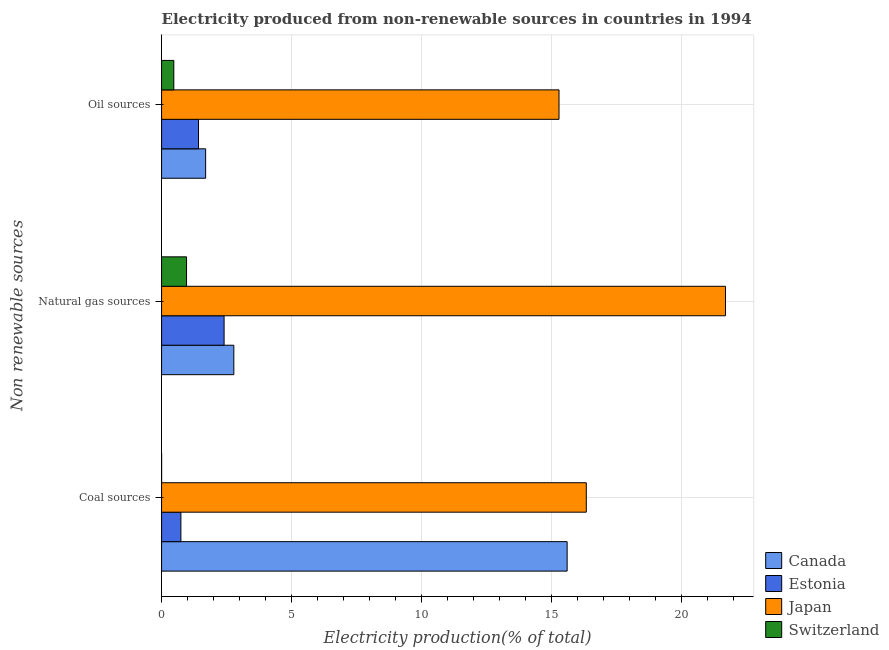How many groups of bars are there?
Keep it short and to the point. 3. Are the number of bars per tick equal to the number of legend labels?
Your answer should be compact. Yes. Are the number of bars on each tick of the Y-axis equal?
Provide a succinct answer. Yes. How many bars are there on the 2nd tick from the top?
Give a very brief answer. 4. What is the label of the 3rd group of bars from the top?
Keep it short and to the point. Coal sources. What is the percentage of electricity produced by oil sources in Estonia?
Ensure brevity in your answer.  1.42. Across all countries, what is the maximum percentage of electricity produced by natural gas?
Provide a succinct answer. 21.68. Across all countries, what is the minimum percentage of electricity produced by oil sources?
Your answer should be compact. 0.47. In which country was the percentage of electricity produced by natural gas minimum?
Provide a succinct answer. Switzerland. What is the total percentage of electricity produced by coal in the graph?
Offer a terse response. 32.67. What is the difference between the percentage of electricity produced by coal in Estonia and that in Switzerland?
Provide a succinct answer. 0.74. What is the difference between the percentage of electricity produced by natural gas in Japan and the percentage of electricity produced by oil sources in Estonia?
Make the answer very short. 20.26. What is the average percentage of electricity produced by oil sources per country?
Your answer should be very brief. 4.72. What is the difference between the percentage of electricity produced by natural gas and percentage of electricity produced by oil sources in Japan?
Offer a very short reply. 6.4. In how many countries, is the percentage of electricity produced by oil sources greater than 5 %?
Your response must be concise. 1. What is the ratio of the percentage of electricity produced by coal in Switzerland to that in Japan?
Keep it short and to the point. 9.359942458074121e-5. Is the difference between the percentage of electricity produced by natural gas in Canada and Switzerland greater than the difference between the percentage of electricity produced by oil sources in Canada and Switzerland?
Ensure brevity in your answer.  Yes. What is the difference between the highest and the second highest percentage of electricity produced by oil sources?
Offer a terse response. 13.59. What is the difference between the highest and the lowest percentage of electricity produced by oil sources?
Offer a terse response. 14.81. What does the 1st bar from the top in Oil sources represents?
Offer a very short reply. Switzerland. What does the 1st bar from the bottom in Oil sources represents?
Give a very brief answer. Canada. Is it the case that in every country, the sum of the percentage of electricity produced by coal and percentage of electricity produced by natural gas is greater than the percentage of electricity produced by oil sources?
Your answer should be compact. Yes. How many countries are there in the graph?
Your answer should be compact. 4. What is the difference between two consecutive major ticks on the X-axis?
Your answer should be very brief. 5. Are the values on the major ticks of X-axis written in scientific E-notation?
Provide a short and direct response. No. Does the graph contain any zero values?
Keep it short and to the point. No. Where does the legend appear in the graph?
Your response must be concise. Bottom right. How are the legend labels stacked?
Your response must be concise. Vertical. What is the title of the graph?
Offer a very short reply. Electricity produced from non-renewable sources in countries in 1994. What is the label or title of the X-axis?
Your answer should be very brief. Electricity production(% of total). What is the label or title of the Y-axis?
Your answer should be compact. Non renewable sources. What is the Electricity production(% of total) of Canada in Coal sources?
Offer a terse response. 15.59. What is the Electricity production(% of total) in Estonia in Coal sources?
Make the answer very short. 0.74. What is the Electricity production(% of total) in Japan in Coal sources?
Provide a succinct answer. 16.33. What is the Electricity production(% of total) in Switzerland in Coal sources?
Your answer should be very brief. 0. What is the Electricity production(% of total) in Canada in Natural gas sources?
Give a very brief answer. 2.78. What is the Electricity production(% of total) of Estonia in Natural gas sources?
Make the answer very short. 2.4. What is the Electricity production(% of total) of Japan in Natural gas sources?
Provide a succinct answer. 21.68. What is the Electricity production(% of total) in Switzerland in Natural gas sources?
Offer a very short reply. 0.96. What is the Electricity production(% of total) of Canada in Oil sources?
Provide a succinct answer. 1.69. What is the Electricity production(% of total) in Estonia in Oil sources?
Offer a terse response. 1.42. What is the Electricity production(% of total) in Japan in Oil sources?
Keep it short and to the point. 15.28. What is the Electricity production(% of total) in Switzerland in Oil sources?
Keep it short and to the point. 0.47. Across all Non renewable sources, what is the maximum Electricity production(% of total) in Canada?
Your answer should be very brief. 15.59. Across all Non renewable sources, what is the maximum Electricity production(% of total) of Estonia?
Your response must be concise. 2.4. Across all Non renewable sources, what is the maximum Electricity production(% of total) of Japan?
Offer a very short reply. 21.68. Across all Non renewable sources, what is the maximum Electricity production(% of total) of Switzerland?
Offer a very short reply. 0.96. Across all Non renewable sources, what is the minimum Electricity production(% of total) of Canada?
Your answer should be compact. 1.69. Across all Non renewable sources, what is the minimum Electricity production(% of total) of Estonia?
Provide a succinct answer. 0.74. Across all Non renewable sources, what is the minimum Electricity production(% of total) in Japan?
Your response must be concise. 15.28. Across all Non renewable sources, what is the minimum Electricity production(% of total) of Switzerland?
Provide a short and direct response. 0. What is the total Electricity production(% of total) in Canada in the graph?
Provide a short and direct response. 20.07. What is the total Electricity production(% of total) of Estonia in the graph?
Offer a very short reply. 4.57. What is the total Electricity production(% of total) of Japan in the graph?
Make the answer very short. 53.29. What is the total Electricity production(% of total) in Switzerland in the graph?
Your response must be concise. 1.43. What is the difference between the Electricity production(% of total) of Canada in Coal sources and that in Natural gas sources?
Provide a short and direct response. 12.82. What is the difference between the Electricity production(% of total) of Estonia in Coal sources and that in Natural gas sources?
Provide a succinct answer. -1.66. What is the difference between the Electricity production(% of total) in Japan in Coal sources and that in Natural gas sources?
Offer a terse response. -5.35. What is the difference between the Electricity production(% of total) of Switzerland in Coal sources and that in Natural gas sources?
Provide a succinct answer. -0.96. What is the difference between the Electricity production(% of total) in Canada in Coal sources and that in Oil sources?
Give a very brief answer. 13.9. What is the difference between the Electricity production(% of total) of Estonia in Coal sources and that in Oil sources?
Offer a very short reply. -0.68. What is the difference between the Electricity production(% of total) in Japan in Coal sources and that in Oil sources?
Offer a very short reply. 1.05. What is the difference between the Electricity production(% of total) of Switzerland in Coal sources and that in Oil sources?
Your answer should be very brief. -0.47. What is the difference between the Electricity production(% of total) of Canada in Natural gas sources and that in Oil sources?
Offer a very short reply. 1.08. What is the difference between the Electricity production(% of total) in Estonia in Natural gas sources and that in Oil sources?
Make the answer very short. 0.98. What is the difference between the Electricity production(% of total) in Japan in Natural gas sources and that in Oil sources?
Your response must be concise. 6.4. What is the difference between the Electricity production(% of total) of Switzerland in Natural gas sources and that in Oil sources?
Your answer should be compact. 0.49. What is the difference between the Electricity production(% of total) of Canada in Coal sources and the Electricity production(% of total) of Estonia in Natural gas sources?
Keep it short and to the point. 13.19. What is the difference between the Electricity production(% of total) of Canada in Coal sources and the Electricity production(% of total) of Japan in Natural gas sources?
Your response must be concise. -6.09. What is the difference between the Electricity production(% of total) in Canada in Coal sources and the Electricity production(% of total) in Switzerland in Natural gas sources?
Give a very brief answer. 14.63. What is the difference between the Electricity production(% of total) of Estonia in Coal sources and the Electricity production(% of total) of Japan in Natural gas sources?
Your answer should be compact. -20.94. What is the difference between the Electricity production(% of total) in Estonia in Coal sources and the Electricity production(% of total) in Switzerland in Natural gas sources?
Ensure brevity in your answer.  -0.22. What is the difference between the Electricity production(% of total) in Japan in Coal sources and the Electricity production(% of total) in Switzerland in Natural gas sources?
Your answer should be very brief. 15.37. What is the difference between the Electricity production(% of total) of Canada in Coal sources and the Electricity production(% of total) of Estonia in Oil sources?
Ensure brevity in your answer.  14.17. What is the difference between the Electricity production(% of total) in Canada in Coal sources and the Electricity production(% of total) in Japan in Oil sources?
Keep it short and to the point. 0.31. What is the difference between the Electricity production(% of total) in Canada in Coal sources and the Electricity production(% of total) in Switzerland in Oil sources?
Provide a succinct answer. 15.12. What is the difference between the Electricity production(% of total) of Estonia in Coal sources and the Electricity production(% of total) of Japan in Oil sources?
Provide a succinct answer. -14.54. What is the difference between the Electricity production(% of total) of Estonia in Coal sources and the Electricity production(% of total) of Switzerland in Oil sources?
Your answer should be compact. 0.27. What is the difference between the Electricity production(% of total) of Japan in Coal sources and the Electricity production(% of total) of Switzerland in Oil sources?
Make the answer very short. 15.86. What is the difference between the Electricity production(% of total) in Canada in Natural gas sources and the Electricity production(% of total) in Estonia in Oil sources?
Offer a very short reply. 1.36. What is the difference between the Electricity production(% of total) of Canada in Natural gas sources and the Electricity production(% of total) of Japan in Oil sources?
Keep it short and to the point. -12.5. What is the difference between the Electricity production(% of total) in Canada in Natural gas sources and the Electricity production(% of total) in Switzerland in Oil sources?
Make the answer very short. 2.31. What is the difference between the Electricity production(% of total) of Estonia in Natural gas sources and the Electricity production(% of total) of Japan in Oil sources?
Keep it short and to the point. -12.88. What is the difference between the Electricity production(% of total) in Estonia in Natural gas sources and the Electricity production(% of total) in Switzerland in Oil sources?
Provide a short and direct response. 1.93. What is the difference between the Electricity production(% of total) in Japan in Natural gas sources and the Electricity production(% of total) in Switzerland in Oil sources?
Your response must be concise. 21.21. What is the average Electricity production(% of total) in Canada per Non renewable sources?
Keep it short and to the point. 6.69. What is the average Electricity production(% of total) in Estonia per Non renewable sources?
Keep it short and to the point. 1.52. What is the average Electricity production(% of total) of Japan per Non renewable sources?
Give a very brief answer. 17.76. What is the average Electricity production(% of total) in Switzerland per Non renewable sources?
Make the answer very short. 0.48. What is the difference between the Electricity production(% of total) in Canada and Electricity production(% of total) in Estonia in Coal sources?
Ensure brevity in your answer.  14.85. What is the difference between the Electricity production(% of total) in Canada and Electricity production(% of total) in Japan in Coal sources?
Your answer should be compact. -0.74. What is the difference between the Electricity production(% of total) of Canada and Electricity production(% of total) of Switzerland in Coal sources?
Provide a succinct answer. 15.59. What is the difference between the Electricity production(% of total) of Estonia and Electricity production(% of total) of Japan in Coal sources?
Your response must be concise. -15.59. What is the difference between the Electricity production(% of total) of Estonia and Electricity production(% of total) of Switzerland in Coal sources?
Make the answer very short. 0.74. What is the difference between the Electricity production(% of total) of Japan and Electricity production(% of total) of Switzerland in Coal sources?
Your answer should be very brief. 16.33. What is the difference between the Electricity production(% of total) in Canada and Electricity production(% of total) in Estonia in Natural gas sources?
Give a very brief answer. 0.37. What is the difference between the Electricity production(% of total) of Canada and Electricity production(% of total) of Japan in Natural gas sources?
Offer a very short reply. -18.9. What is the difference between the Electricity production(% of total) in Canada and Electricity production(% of total) in Switzerland in Natural gas sources?
Provide a short and direct response. 1.82. What is the difference between the Electricity production(% of total) in Estonia and Electricity production(% of total) in Japan in Natural gas sources?
Your response must be concise. -19.28. What is the difference between the Electricity production(% of total) in Estonia and Electricity production(% of total) in Switzerland in Natural gas sources?
Ensure brevity in your answer.  1.44. What is the difference between the Electricity production(% of total) of Japan and Electricity production(% of total) of Switzerland in Natural gas sources?
Ensure brevity in your answer.  20.72. What is the difference between the Electricity production(% of total) of Canada and Electricity production(% of total) of Estonia in Oil sources?
Provide a short and direct response. 0.27. What is the difference between the Electricity production(% of total) of Canada and Electricity production(% of total) of Japan in Oil sources?
Your answer should be compact. -13.59. What is the difference between the Electricity production(% of total) in Canada and Electricity production(% of total) in Switzerland in Oil sources?
Give a very brief answer. 1.22. What is the difference between the Electricity production(% of total) in Estonia and Electricity production(% of total) in Japan in Oil sources?
Offer a very short reply. -13.86. What is the difference between the Electricity production(% of total) in Estonia and Electricity production(% of total) in Switzerland in Oil sources?
Your response must be concise. 0.95. What is the difference between the Electricity production(% of total) in Japan and Electricity production(% of total) in Switzerland in Oil sources?
Your answer should be very brief. 14.81. What is the ratio of the Electricity production(% of total) in Canada in Coal sources to that in Natural gas sources?
Give a very brief answer. 5.61. What is the ratio of the Electricity production(% of total) of Estonia in Coal sources to that in Natural gas sources?
Make the answer very short. 0.31. What is the ratio of the Electricity production(% of total) of Japan in Coal sources to that in Natural gas sources?
Keep it short and to the point. 0.75. What is the ratio of the Electricity production(% of total) of Switzerland in Coal sources to that in Natural gas sources?
Keep it short and to the point. 0. What is the ratio of the Electricity production(% of total) in Canada in Coal sources to that in Oil sources?
Your answer should be compact. 9.2. What is the ratio of the Electricity production(% of total) in Estonia in Coal sources to that in Oil sources?
Your response must be concise. 0.52. What is the ratio of the Electricity production(% of total) in Japan in Coal sources to that in Oil sources?
Your answer should be compact. 1.07. What is the ratio of the Electricity production(% of total) in Switzerland in Coal sources to that in Oil sources?
Provide a succinct answer. 0. What is the ratio of the Electricity production(% of total) of Canada in Natural gas sources to that in Oil sources?
Give a very brief answer. 1.64. What is the ratio of the Electricity production(% of total) in Estonia in Natural gas sources to that in Oil sources?
Offer a very short reply. 1.69. What is the ratio of the Electricity production(% of total) of Japan in Natural gas sources to that in Oil sources?
Ensure brevity in your answer.  1.42. What is the ratio of the Electricity production(% of total) in Switzerland in Natural gas sources to that in Oil sources?
Give a very brief answer. 2.04. What is the difference between the highest and the second highest Electricity production(% of total) in Canada?
Give a very brief answer. 12.82. What is the difference between the highest and the second highest Electricity production(% of total) of Estonia?
Ensure brevity in your answer.  0.98. What is the difference between the highest and the second highest Electricity production(% of total) of Japan?
Make the answer very short. 5.35. What is the difference between the highest and the second highest Electricity production(% of total) of Switzerland?
Keep it short and to the point. 0.49. What is the difference between the highest and the lowest Electricity production(% of total) in Canada?
Your answer should be very brief. 13.9. What is the difference between the highest and the lowest Electricity production(% of total) in Estonia?
Your answer should be compact. 1.66. What is the difference between the highest and the lowest Electricity production(% of total) in Japan?
Provide a short and direct response. 6.4. What is the difference between the highest and the lowest Electricity production(% of total) in Switzerland?
Keep it short and to the point. 0.96. 